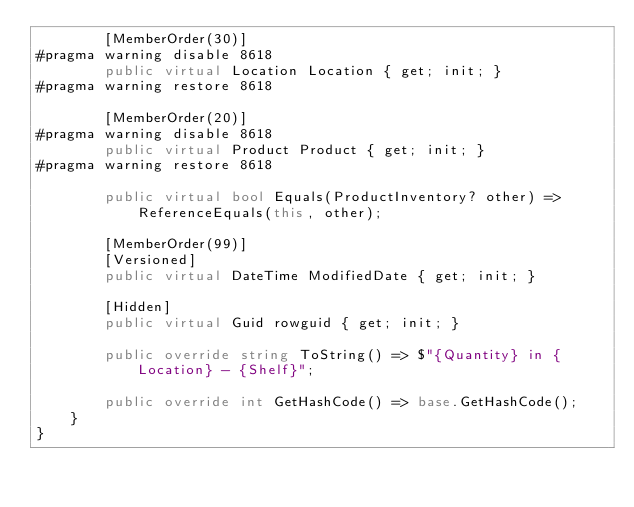Convert code to text. <code><loc_0><loc_0><loc_500><loc_500><_C#_>        [MemberOrder(30)]
#pragma warning disable 8618
        public virtual Location Location { get; init; }
#pragma warning restore 8618

        [MemberOrder(20)]
#pragma warning disable 8618
        public virtual Product Product { get; init; }
#pragma warning restore 8618

        public virtual bool Equals(ProductInventory? other) => ReferenceEquals(this, other);

        [MemberOrder(99)]
        [Versioned]
        public virtual DateTime ModifiedDate { get; init; }

        [Hidden]
        public virtual Guid rowguid { get; init; }

        public override string ToString() => $"{Quantity} in {Location} - {Shelf}";

        public override int GetHashCode() => base.GetHashCode();
    }
}</code> 